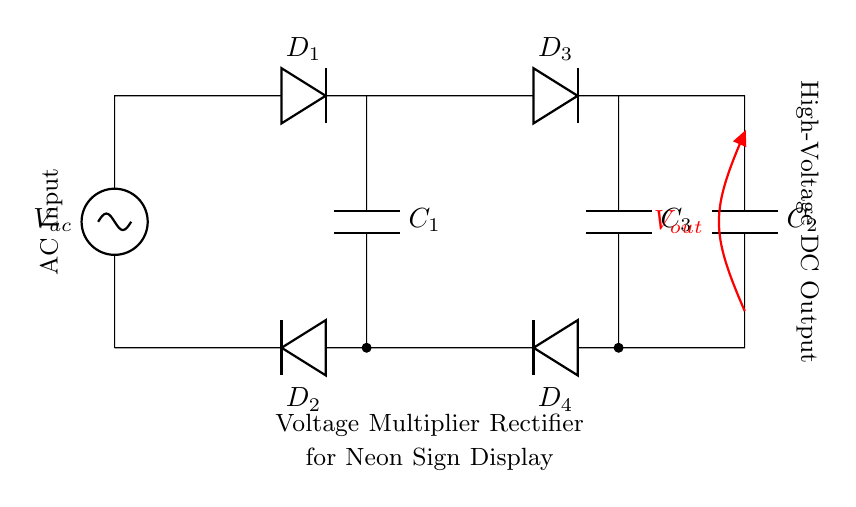What is the input type of this circuit? The circuit takes an alternating current (AC) input, as indicated by the component label sV, which stands for a voltage source in AC configuration at the left side of the diagram.
Answer: AC How many capacitors are present in the circuit? There are three capacitors labeled C1, C2, and C3 in the circuit diagram, which can be counted visually from the symbols provided on the diagram.
Answer: 3 What is the purpose of the diodes in this rectifier circuit? The diodes in this circuit function as rectifying elements that allow current to flow in one direction only, thus converting AC voltage from the input into high-voltage DC output. This is indicated by their arrangement in the circuit where they are connected to the output load.
Answer: Rectification What is the output voltage denoted in the circuit? The output voltage is labeled as Vout, which is represented as an open endpoint indicating the high-voltage DC output taken from the last capacitor in the circuit.
Answer: Vout How are the capacitors connected in this circuit? The capacitors are connected in parallel to the output of each diode, which helps to smooth out the voltage fluctuations, as can be seen from the connections branching off from the diodes to the capacitors.
Answer: Parallel What type of circuit is depicted here? This circuit is a voltage multiplier rectifier, as indicated in the central label of the circuit diagram which explicitly states its purpose, allowing for the transformation from AC to high-voltage DC necessary for neon signs.
Answer: Voltage Multiplier Rectifier 